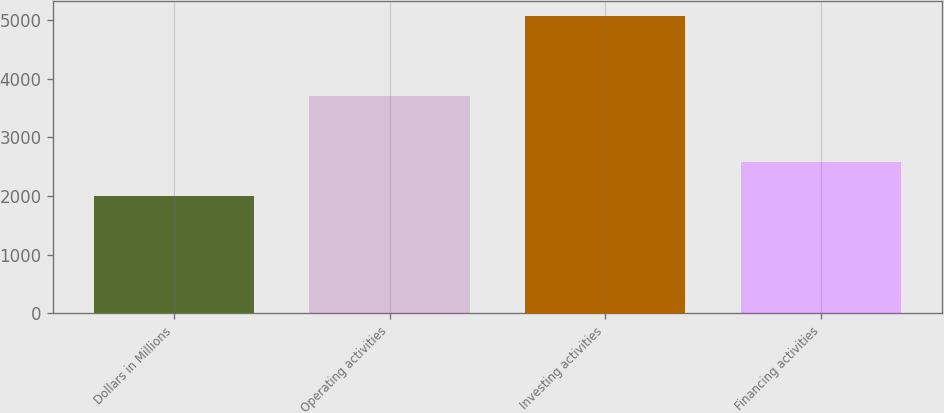Convert chart. <chart><loc_0><loc_0><loc_500><loc_500><bar_chart><fcel>Dollars in Millions<fcel>Operating activities<fcel>Investing activities<fcel>Financing activities<nl><fcel>2008<fcel>3707<fcel>5079<fcel>2582<nl></chart> 